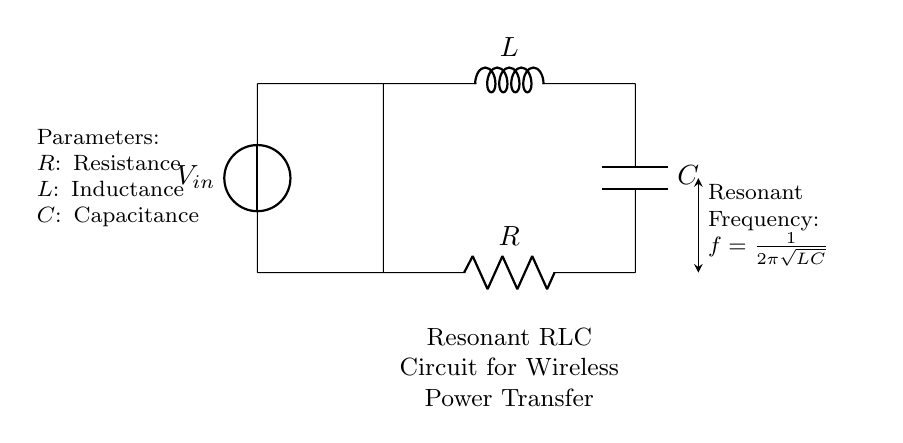What components are used in this circuit? The circuit contains three main components: a resistor, an inductor, and a capacitor. These are labeled R, L, and C respectively in the diagram.
Answer: Resistor, Inductor, Capacitor What is the role of the resistor in this circuit? The resistor serves to limit current and dissipate energy in the form of heat, which can affect the overall performance of the circuit, particularly the damping factor.
Answer: Limit current, dissipate energy What is the formula for resonant frequency? The circuit shows the resonant frequency formula as f = 1/(2π√(LC)), which represents how frequency depends on inductance and capacitance.
Answer: f = 1/(2π√(LC)) How does increasing capacitance affect the resonant frequency? Increasing the capacitance C decreases the value inside the square root in the resonant frequency formula, which leads to a lower resonant frequency.
Answer: Decreases resonant frequency What happens to the resonant frequency if inductance is doubled? If the inductance L is doubled, the square root in the resonant frequency formula increases, which causes the resonant frequency to decrease.
Answer: Decreases resonant frequency What type of circuit is represented? This circuit is specifically classified as a resonant RLC circuit, recognized by the use of a resistor, inductor, and capacitor arranged to operate at a specific resonant frequency for energy transfer.
Answer: Resonant RLC circuit At what point does maximum energy transfer occur in this circuit? Maximum energy transfer in a resonant RLC circuit occurs at the resonant frequency, where the circuit can efficiently transfer power between components without losses.
Answer: At resonant frequency 